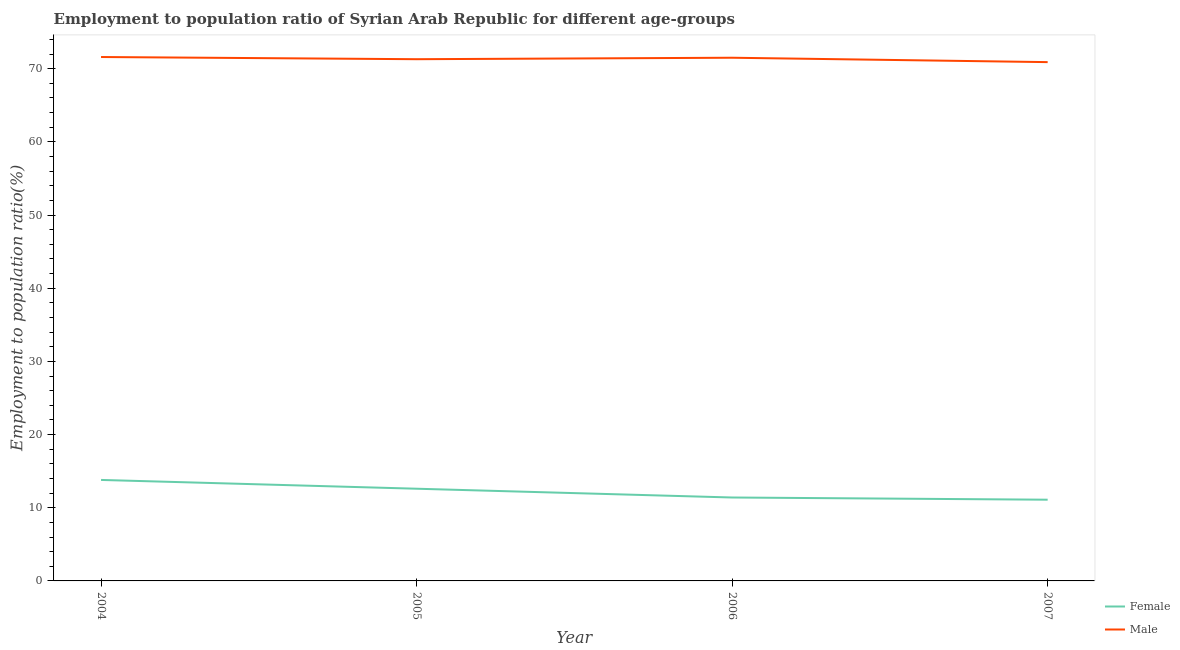Is the number of lines equal to the number of legend labels?
Offer a very short reply. Yes. What is the employment to population ratio(female) in 2004?
Your answer should be very brief. 13.8. Across all years, what is the maximum employment to population ratio(male)?
Your answer should be compact. 71.6. Across all years, what is the minimum employment to population ratio(male)?
Keep it short and to the point. 70.9. In which year was the employment to population ratio(female) minimum?
Make the answer very short. 2007. What is the total employment to population ratio(male) in the graph?
Your answer should be very brief. 285.3. What is the difference between the employment to population ratio(female) in 2004 and that in 2005?
Offer a very short reply. 1.2. What is the difference between the employment to population ratio(male) in 2006 and the employment to population ratio(female) in 2007?
Provide a short and direct response. 60.4. What is the average employment to population ratio(female) per year?
Provide a succinct answer. 12.23. In the year 2007, what is the difference between the employment to population ratio(male) and employment to population ratio(female)?
Keep it short and to the point. 59.8. What is the ratio of the employment to population ratio(female) in 2006 to that in 2007?
Offer a terse response. 1.03. Is the difference between the employment to population ratio(female) in 2004 and 2005 greater than the difference between the employment to population ratio(male) in 2004 and 2005?
Offer a very short reply. Yes. What is the difference between the highest and the second highest employment to population ratio(male)?
Your response must be concise. 0.1. What is the difference between the highest and the lowest employment to population ratio(male)?
Offer a terse response. 0.7. Does the employment to population ratio(male) monotonically increase over the years?
Provide a succinct answer. No. Is the employment to population ratio(female) strictly less than the employment to population ratio(male) over the years?
Your answer should be compact. Yes. How many lines are there?
Your answer should be compact. 2. How many years are there in the graph?
Provide a succinct answer. 4. What is the difference between two consecutive major ticks on the Y-axis?
Keep it short and to the point. 10. Are the values on the major ticks of Y-axis written in scientific E-notation?
Make the answer very short. No. Does the graph contain grids?
Provide a short and direct response. No. Where does the legend appear in the graph?
Offer a very short reply. Bottom right. What is the title of the graph?
Keep it short and to the point. Employment to population ratio of Syrian Arab Republic for different age-groups. Does "Travel services" appear as one of the legend labels in the graph?
Offer a terse response. No. What is the label or title of the X-axis?
Your answer should be compact. Year. What is the Employment to population ratio(%) in Female in 2004?
Ensure brevity in your answer.  13.8. What is the Employment to population ratio(%) of Male in 2004?
Make the answer very short. 71.6. What is the Employment to population ratio(%) of Female in 2005?
Offer a terse response. 12.6. What is the Employment to population ratio(%) in Male in 2005?
Provide a succinct answer. 71.3. What is the Employment to population ratio(%) in Female in 2006?
Keep it short and to the point. 11.4. What is the Employment to population ratio(%) of Male in 2006?
Make the answer very short. 71.5. What is the Employment to population ratio(%) in Female in 2007?
Offer a very short reply. 11.1. What is the Employment to population ratio(%) in Male in 2007?
Offer a terse response. 70.9. Across all years, what is the maximum Employment to population ratio(%) in Female?
Provide a succinct answer. 13.8. Across all years, what is the maximum Employment to population ratio(%) in Male?
Offer a very short reply. 71.6. Across all years, what is the minimum Employment to population ratio(%) in Female?
Offer a terse response. 11.1. Across all years, what is the minimum Employment to population ratio(%) in Male?
Your answer should be very brief. 70.9. What is the total Employment to population ratio(%) of Female in the graph?
Your answer should be compact. 48.9. What is the total Employment to population ratio(%) in Male in the graph?
Keep it short and to the point. 285.3. What is the difference between the Employment to population ratio(%) in Female in 2004 and that in 2005?
Your answer should be very brief. 1.2. What is the difference between the Employment to population ratio(%) in Male in 2004 and that in 2005?
Ensure brevity in your answer.  0.3. What is the difference between the Employment to population ratio(%) in Male in 2004 and that in 2006?
Ensure brevity in your answer.  0.1. What is the difference between the Employment to population ratio(%) of Female in 2005 and that in 2006?
Offer a terse response. 1.2. What is the difference between the Employment to population ratio(%) in Male in 2005 and that in 2006?
Your answer should be very brief. -0.2. What is the difference between the Employment to population ratio(%) in Female in 2005 and that in 2007?
Offer a very short reply. 1.5. What is the difference between the Employment to population ratio(%) of Female in 2004 and the Employment to population ratio(%) of Male in 2005?
Offer a very short reply. -57.5. What is the difference between the Employment to population ratio(%) of Female in 2004 and the Employment to population ratio(%) of Male in 2006?
Keep it short and to the point. -57.7. What is the difference between the Employment to population ratio(%) of Female in 2004 and the Employment to population ratio(%) of Male in 2007?
Offer a terse response. -57.1. What is the difference between the Employment to population ratio(%) in Female in 2005 and the Employment to population ratio(%) in Male in 2006?
Your response must be concise. -58.9. What is the difference between the Employment to population ratio(%) in Female in 2005 and the Employment to population ratio(%) in Male in 2007?
Keep it short and to the point. -58.3. What is the difference between the Employment to population ratio(%) in Female in 2006 and the Employment to population ratio(%) in Male in 2007?
Make the answer very short. -59.5. What is the average Employment to population ratio(%) of Female per year?
Give a very brief answer. 12.22. What is the average Employment to population ratio(%) of Male per year?
Ensure brevity in your answer.  71.33. In the year 2004, what is the difference between the Employment to population ratio(%) in Female and Employment to population ratio(%) in Male?
Provide a succinct answer. -57.8. In the year 2005, what is the difference between the Employment to population ratio(%) in Female and Employment to population ratio(%) in Male?
Your answer should be compact. -58.7. In the year 2006, what is the difference between the Employment to population ratio(%) in Female and Employment to population ratio(%) in Male?
Keep it short and to the point. -60.1. In the year 2007, what is the difference between the Employment to population ratio(%) of Female and Employment to population ratio(%) of Male?
Give a very brief answer. -59.8. What is the ratio of the Employment to population ratio(%) of Female in 2004 to that in 2005?
Provide a short and direct response. 1.1. What is the ratio of the Employment to population ratio(%) of Male in 2004 to that in 2005?
Keep it short and to the point. 1. What is the ratio of the Employment to population ratio(%) in Female in 2004 to that in 2006?
Provide a short and direct response. 1.21. What is the ratio of the Employment to population ratio(%) in Female in 2004 to that in 2007?
Provide a succinct answer. 1.24. What is the ratio of the Employment to population ratio(%) in Male in 2004 to that in 2007?
Your response must be concise. 1.01. What is the ratio of the Employment to population ratio(%) in Female in 2005 to that in 2006?
Provide a short and direct response. 1.11. What is the ratio of the Employment to population ratio(%) in Male in 2005 to that in 2006?
Provide a short and direct response. 1. What is the ratio of the Employment to population ratio(%) in Female in 2005 to that in 2007?
Your answer should be very brief. 1.14. What is the ratio of the Employment to population ratio(%) of Male in 2005 to that in 2007?
Ensure brevity in your answer.  1.01. What is the ratio of the Employment to population ratio(%) of Female in 2006 to that in 2007?
Offer a terse response. 1.03. What is the ratio of the Employment to population ratio(%) in Male in 2006 to that in 2007?
Make the answer very short. 1.01. What is the difference between the highest and the second highest Employment to population ratio(%) of Male?
Your response must be concise. 0.1. 